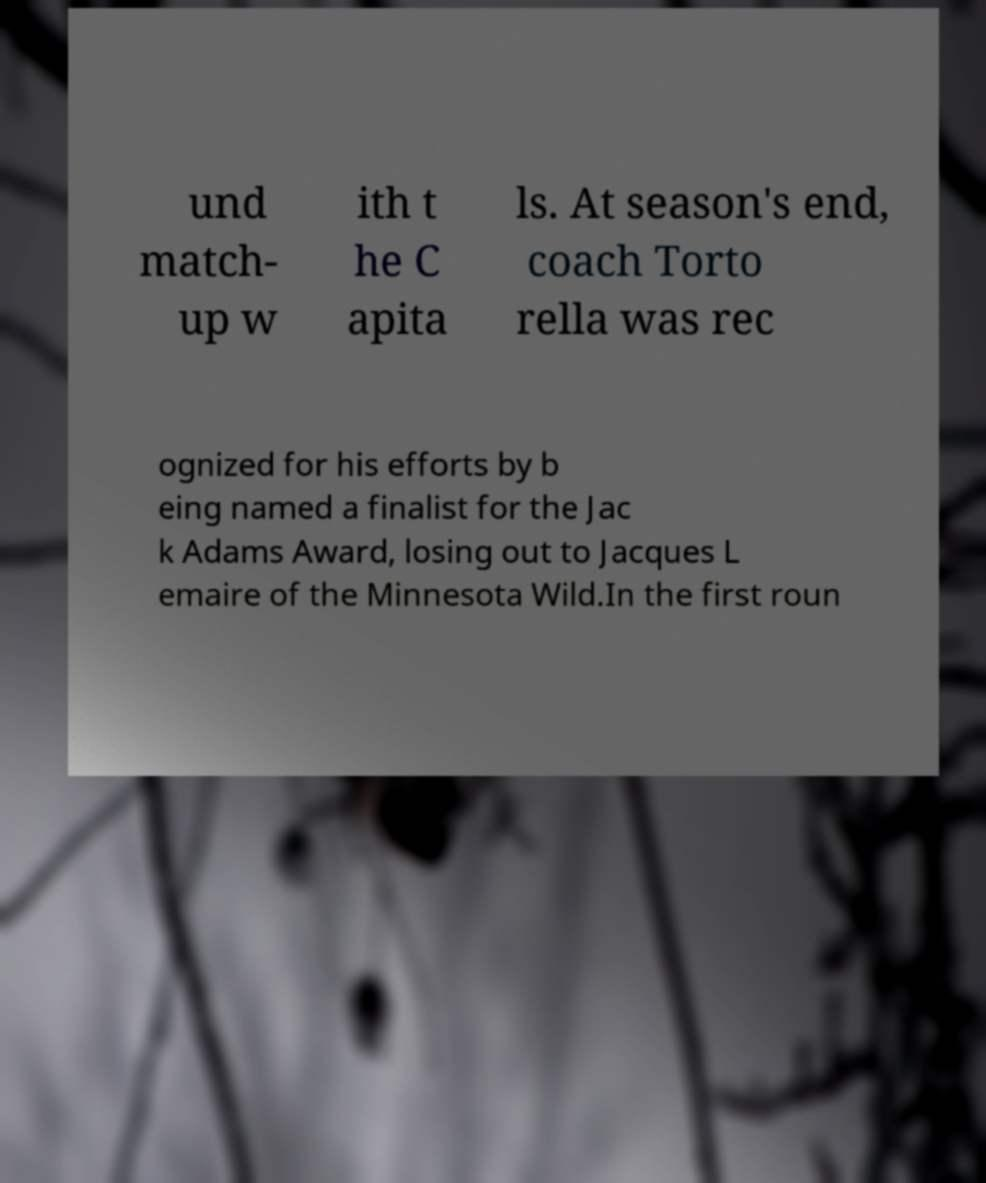Please identify and transcribe the text found in this image. und match- up w ith t he C apita ls. At season's end, coach Torto rella was rec ognized for his efforts by b eing named a finalist for the Jac k Adams Award, losing out to Jacques L emaire of the Minnesota Wild.In the first roun 